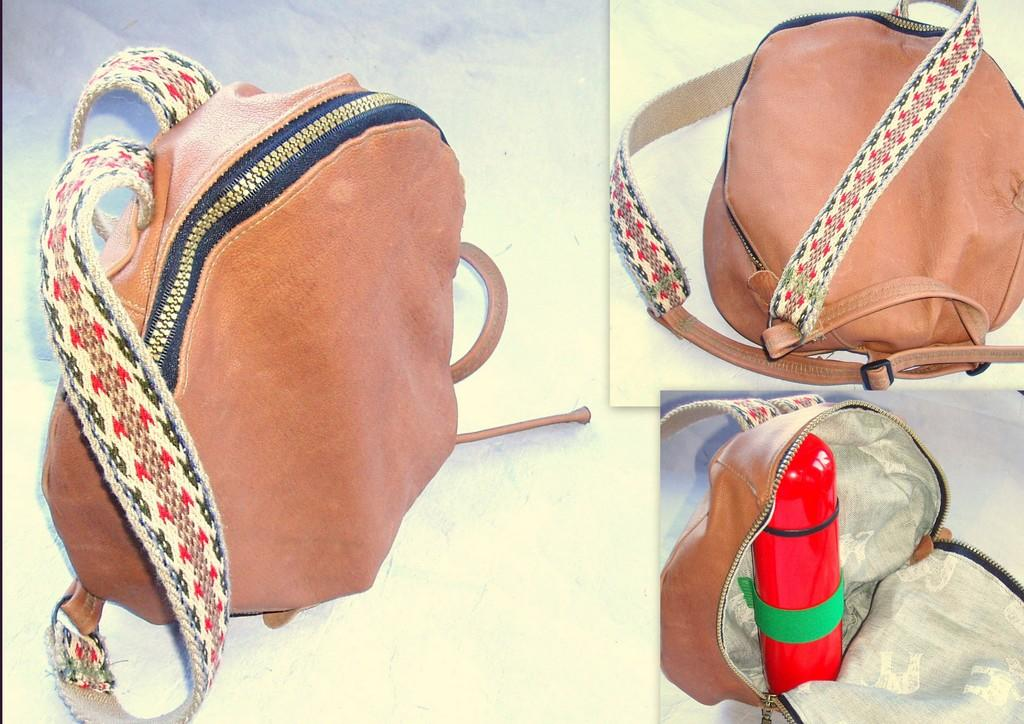What is the main subject of the image? The main subject of the image is a collage of a bag. Can you describe any specific items within the bag? Yes, there is a bottle in the bottom right side of the bag. What type of vest can be seen hanging on the fence in the image? There is no vest or fence present in the image; it is a collage of a bag with a bottle inside. 